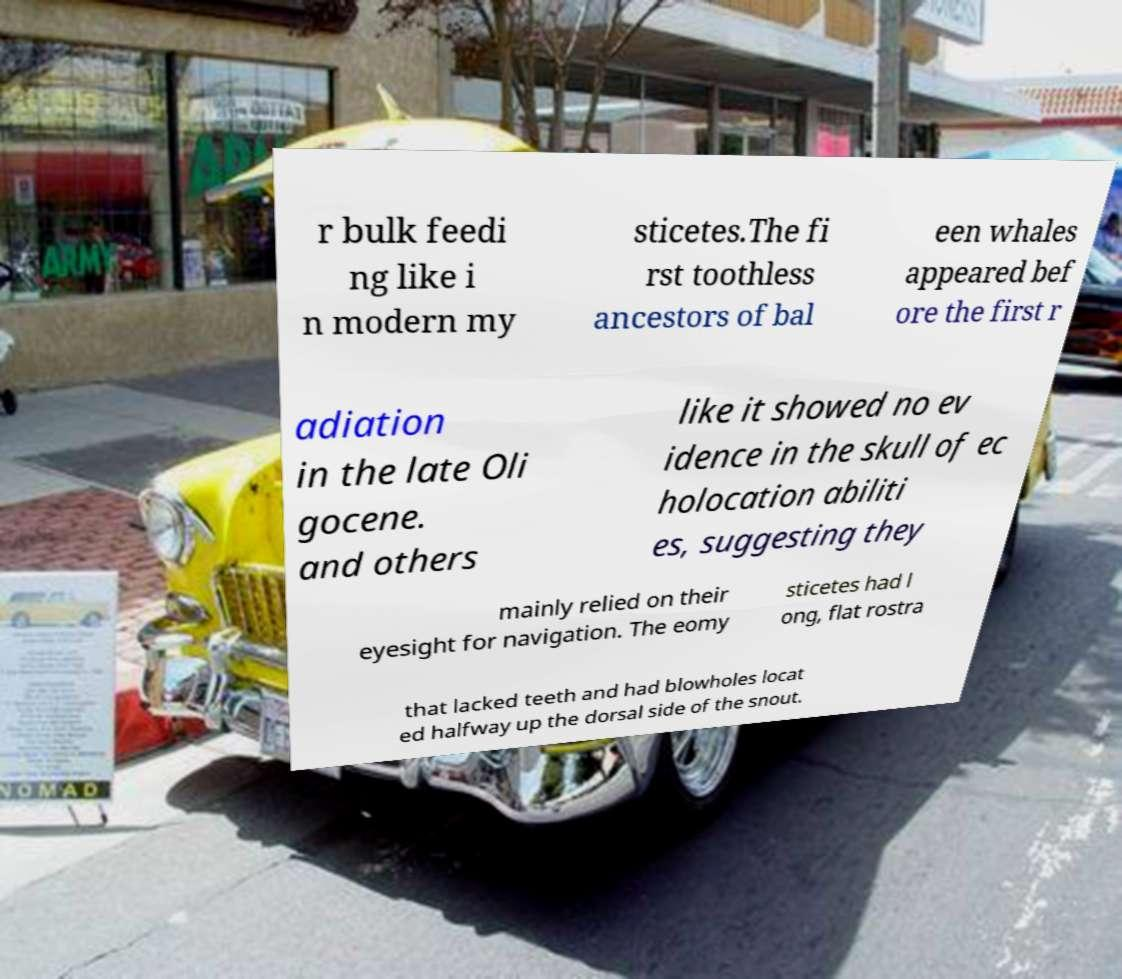Could you extract and type out the text from this image? r bulk feedi ng like i n modern my sticetes.The fi rst toothless ancestors of bal een whales appeared bef ore the first r adiation in the late Oli gocene. and others like it showed no ev idence in the skull of ec holocation abiliti es, suggesting they mainly relied on their eyesight for navigation. The eomy sticetes had l ong, flat rostra that lacked teeth and had blowholes locat ed halfway up the dorsal side of the snout. 